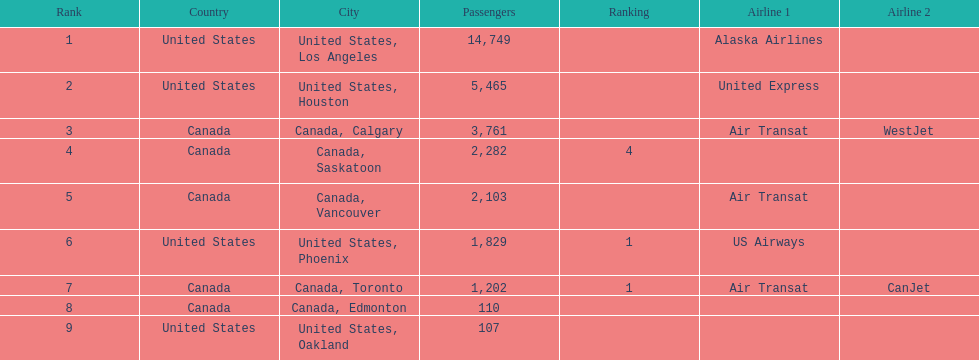Which canadian city had the most passengers traveling from manzanillo international airport in 2013? Calgary. 